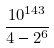<formula> <loc_0><loc_0><loc_500><loc_500>\frac { 1 0 ^ { 1 4 3 } } { 4 - 2 ^ { 6 } }</formula> 